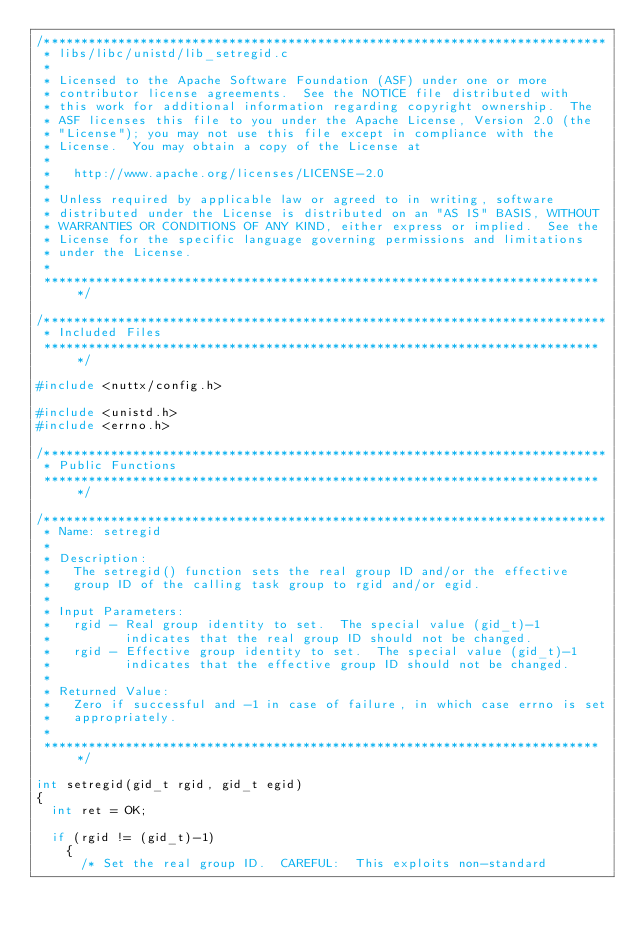Convert code to text. <code><loc_0><loc_0><loc_500><loc_500><_C_>/****************************************************************************
 * libs/libc/unistd/lib_setregid.c
 *
 * Licensed to the Apache Software Foundation (ASF) under one or more
 * contributor license agreements.  See the NOTICE file distributed with
 * this work for additional information regarding copyright ownership.  The
 * ASF licenses this file to you under the Apache License, Version 2.0 (the
 * "License"); you may not use this file except in compliance with the
 * License.  You may obtain a copy of the License at
 *
 *   http://www.apache.org/licenses/LICENSE-2.0
 *
 * Unless required by applicable law or agreed to in writing, software
 * distributed under the License is distributed on an "AS IS" BASIS, WITHOUT
 * WARRANTIES OR CONDITIONS OF ANY KIND, either express or implied.  See the
 * License for the specific language governing permissions and limitations
 * under the License.
 *
 ****************************************************************************/

/****************************************************************************
 * Included Files
 ****************************************************************************/

#include <nuttx/config.h>

#include <unistd.h>
#include <errno.h>

/****************************************************************************
 * Public Functions
 ****************************************************************************/

/****************************************************************************
 * Name: setregid
 *
 * Description:
 *   The setregid() function sets the real group ID and/or the effective
 *   group ID of the calling task group to rgid and/or egid.
 *
 * Input Parameters:
 *   rgid - Real group identity to set.  The special value (gid_t)-1
 *          indicates that the real group ID should not be changed.
 *   rgid - Effective group identity to set.  The special value (gid_t)-1
 *          indicates that the effective group ID should not be changed.
 *
 * Returned Value:
 *   Zero if successful and -1 in case of failure, in which case errno is set
 *   appropriately.
 *
 ****************************************************************************/

int setregid(gid_t rgid, gid_t egid)
{
  int ret = OK;

  if (rgid != (gid_t)-1)
    {
      /* Set the real group ID.  CAREFUL:  This exploits non-standard</code> 